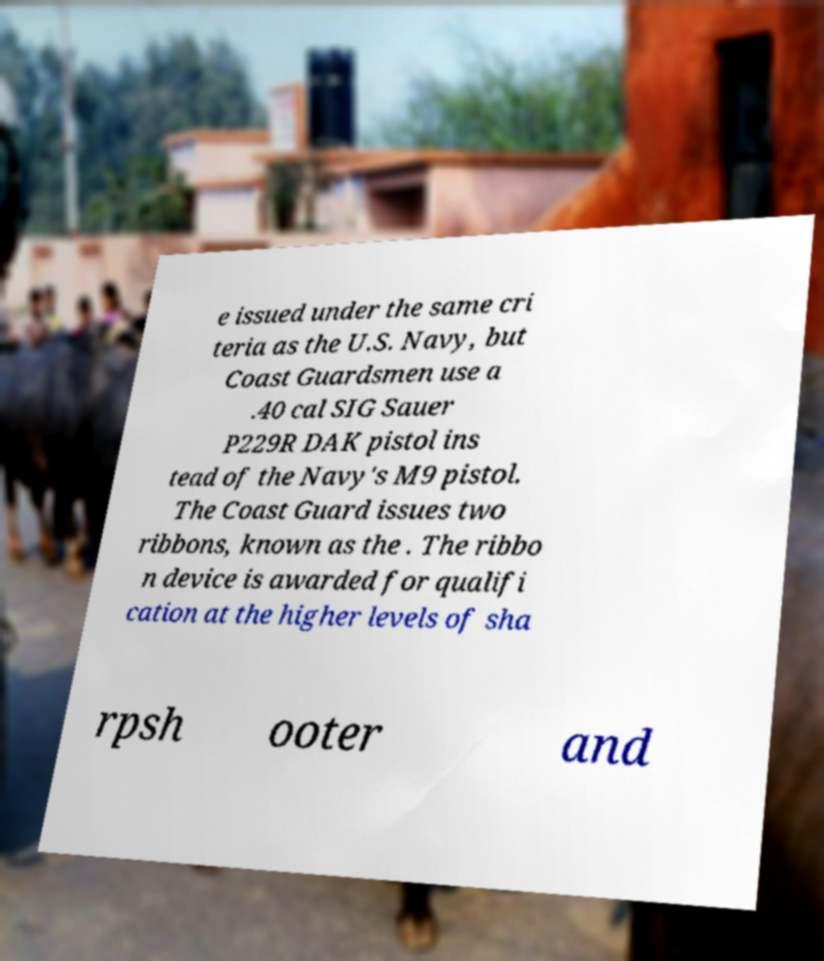Can you read and provide the text displayed in the image?This photo seems to have some interesting text. Can you extract and type it out for me? e issued under the same cri teria as the U.S. Navy, but Coast Guardsmen use a .40 cal SIG Sauer P229R DAK pistol ins tead of the Navy's M9 pistol. The Coast Guard issues two ribbons, known as the . The ribbo n device is awarded for qualifi cation at the higher levels of sha rpsh ooter and 